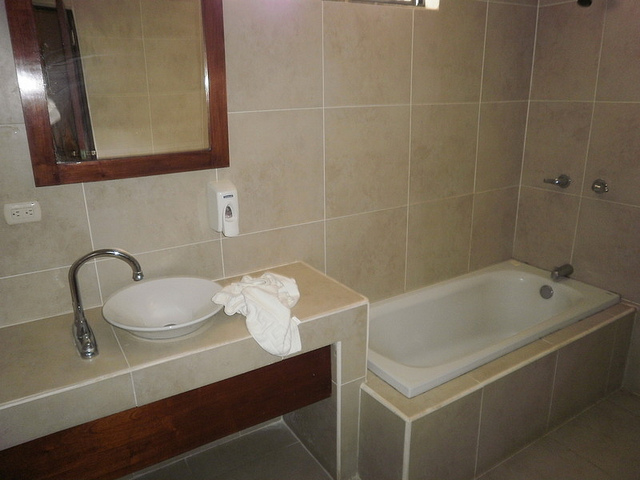<image>What decor is on the tile? I don't know what the decor on the tile is. It could be squares, beige, marble, plain, brown or there might be no decor at all. What decor is on the tile? I am not sure what decor is on the tile. There can be squares, beige, marble, plain, or brown decor. 